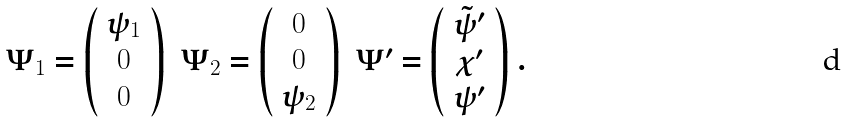Convert formula to latex. <formula><loc_0><loc_0><loc_500><loc_500>\begin{array} { c c c } \Psi _ { 1 } = \left ( \begin{array} { c } \psi _ { 1 } \\ 0 \\ 0 \end{array} \right ) & \Psi _ { 2 } = \left ( \begin{array} { c } 0 \\ 0 \\ \psi _ { 2 } \end{array} \right ) & \Psi ^ { \prime } = \left ( \begin{array} { c } \tilde { \psi } ^ { \prime } \\ \chi ^ { \prime } \\ \psi ^ { \prime } \end{array} \right ) \end{array} .</formula> 